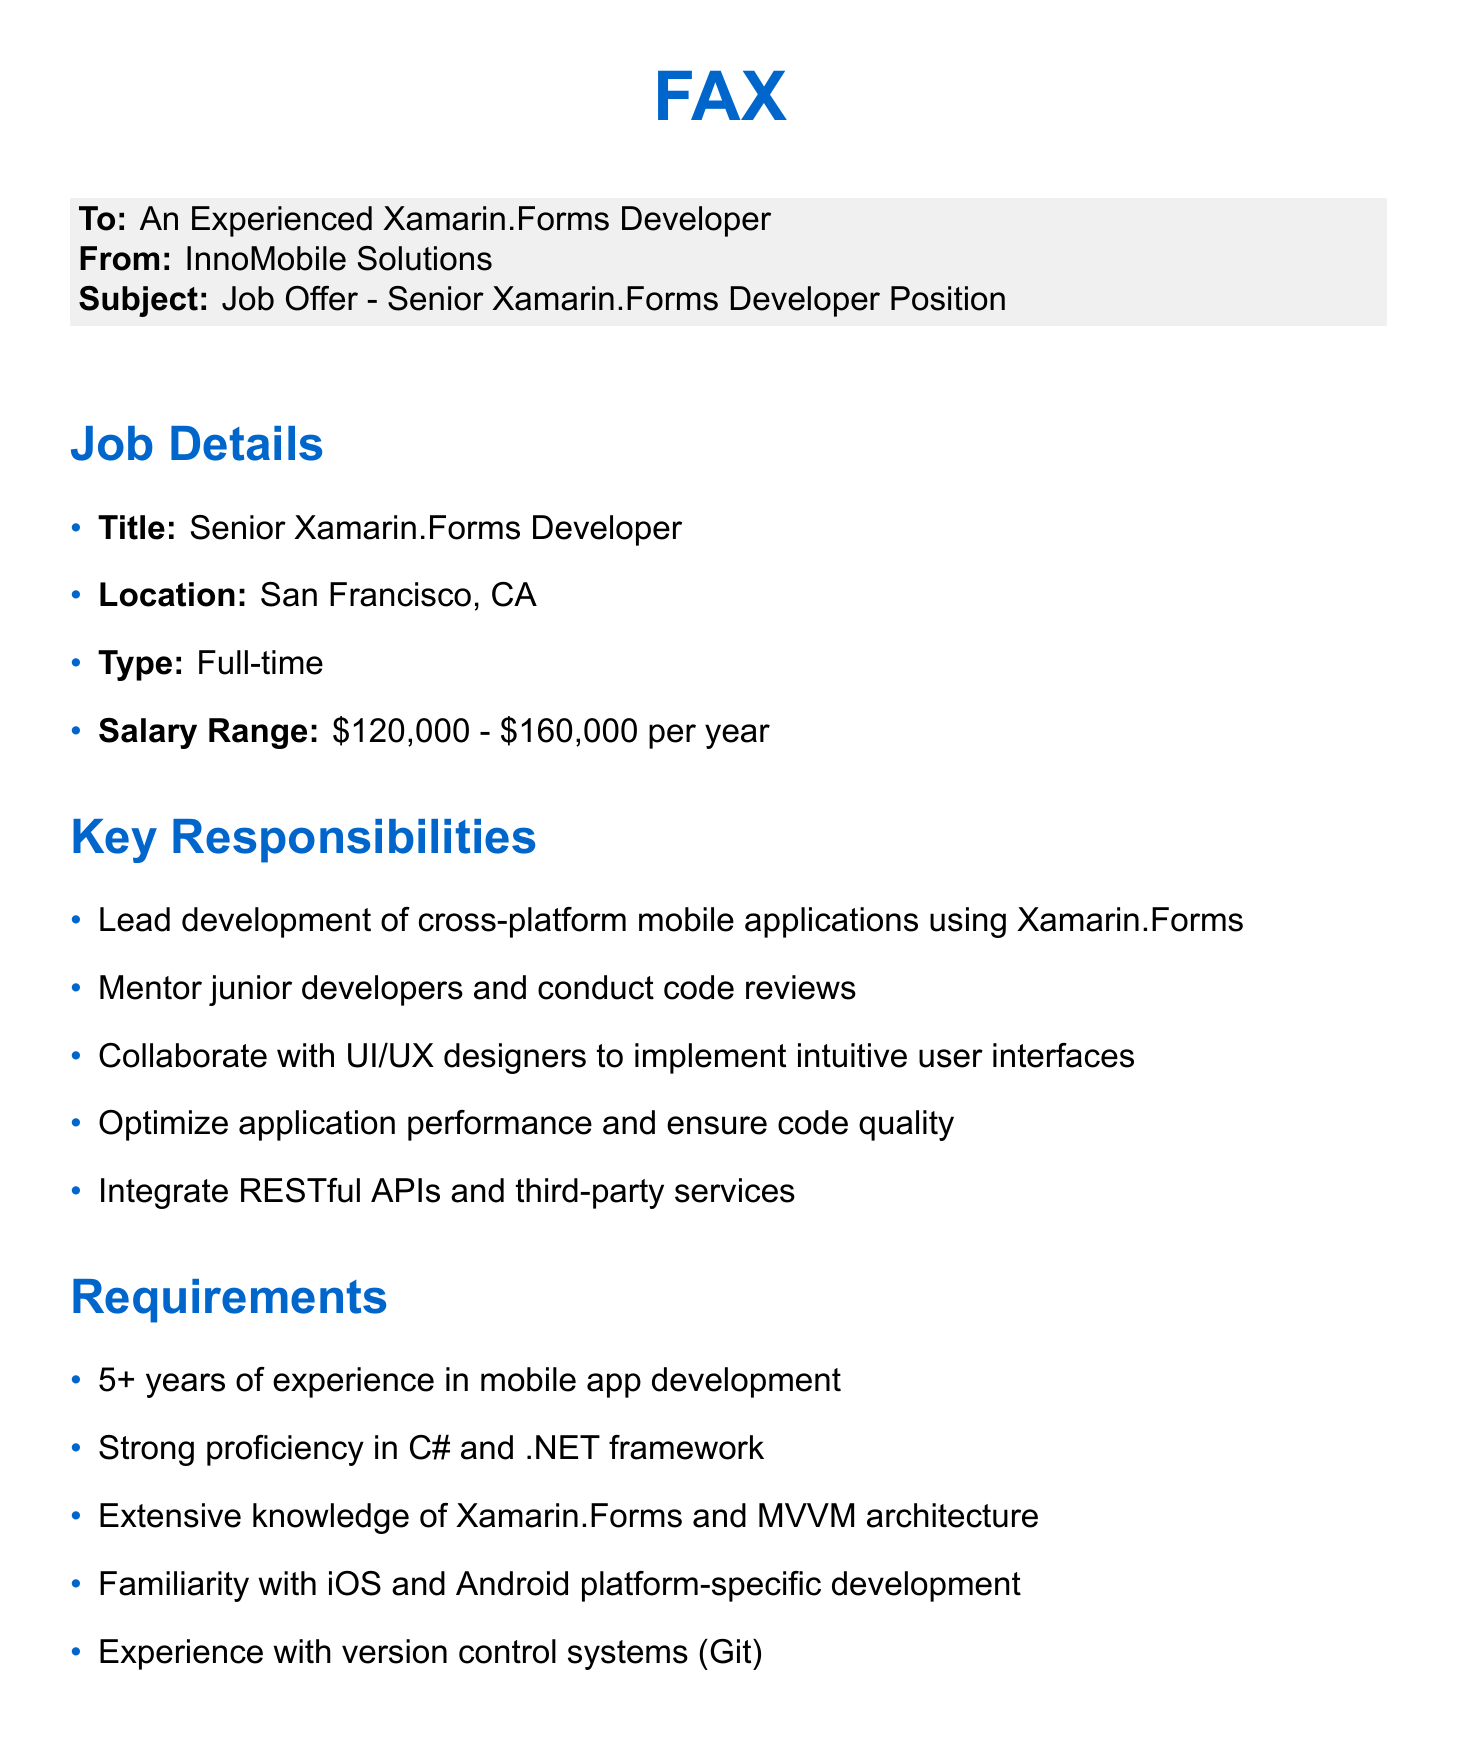What is the job title? The job title mentioned in the document is "Senior Xamarin.Forms Developer."
Answer: Senior Xamarin.Forms Developer What is the salary range? The document states a salary range from $120,000 to $160,000 per year.
Answer: $120,000 - $160,000 per year What are the key responsibilities? Key responsibilities include leading development of cross-platform mobile applications, mentoring junior developers, and collaborating with UI/UX designers.
Answer: Lead development of cross-platform mobile applications How many years of experience are required? The document specifies that 5+ years of experience in mobile app development is required.
Answer: 5+ years What benefits are mentioned? Benefits listed in the document include competitive salary, health insurance, and flexible work hours.
Answer: Competitive salary and performance bonuses What is the location of the job? The document indicates that the job is located in San Francisco, CA.
Answer: San Francisco, CA How can applicants apply? Applicants can send their resume and portfolio to careers@innomobile.com as per the document.
Answer: careers@innomobile.com What is the final step of the application process? The final step mentioned in the application process is an on-site interview with the team.
Answer: Final on-site interview with the team What is the company name? The company name mentioned in the document is InnoMobile Solutions.
Answer: InnoMobile Solutions 